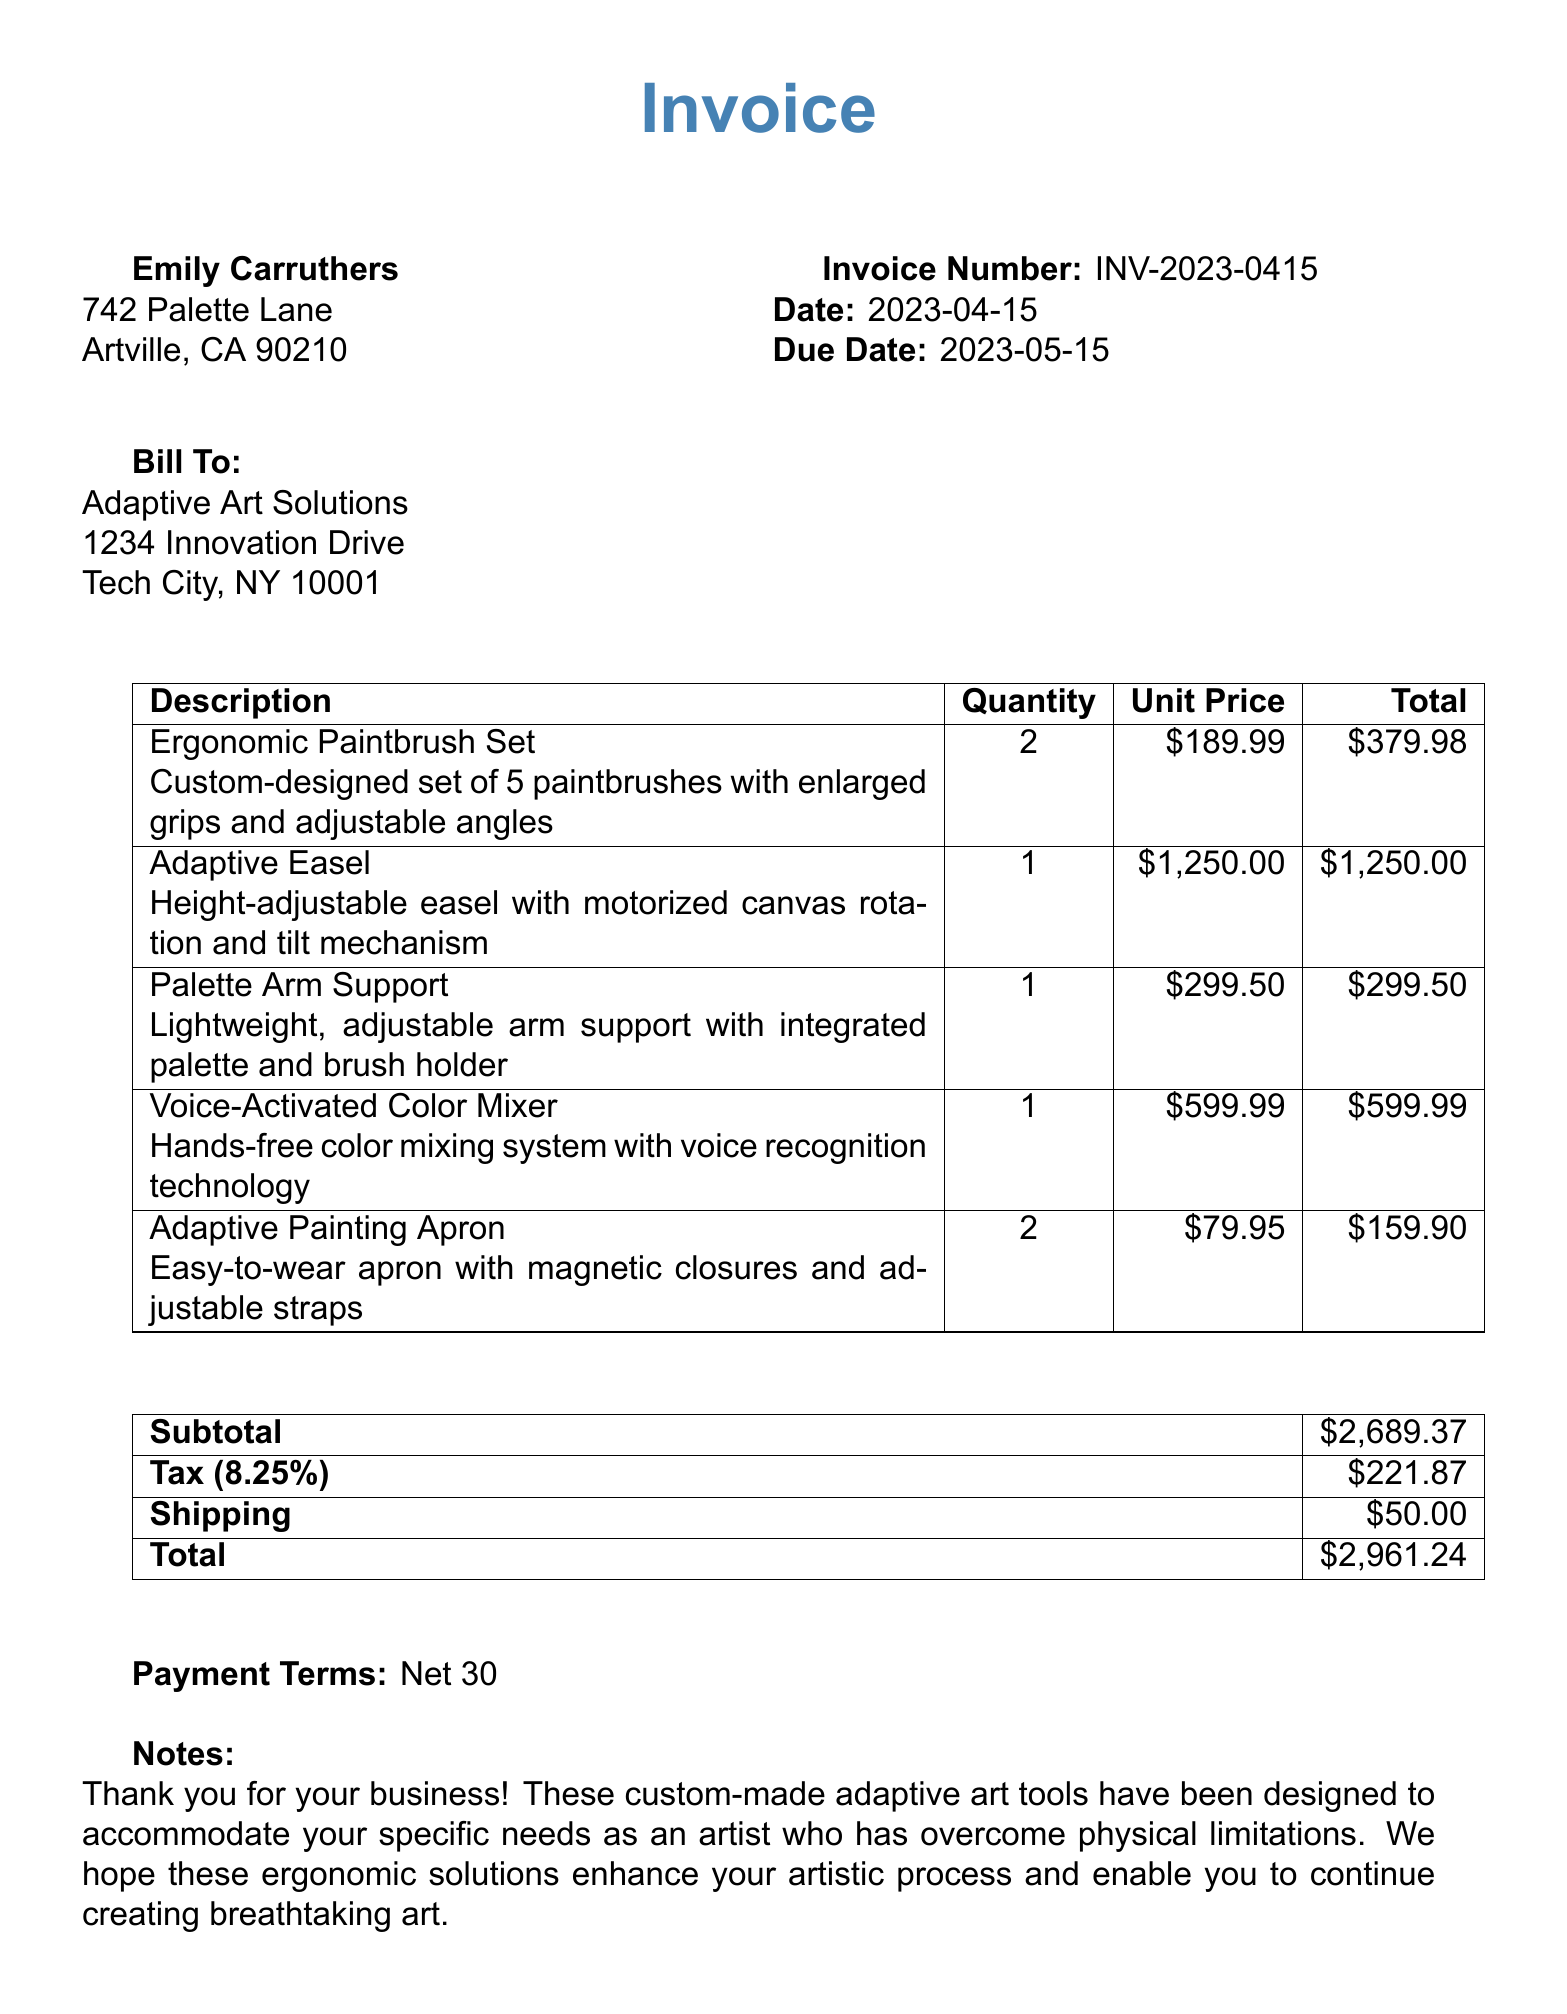What is the invoice number? The invoice number is clearly listed in the document, specifically noted as INV-2023-0415.
Answer: INV-2023-0415 What is the date of the invoice? The date of the invoice is provided in the document, stated as April 15, 2023.
Answer: 2023-04-15 How many ergonomic paintbrush sets were ordered? The quantity of ergonomic paintbrush sets is specified in the item list section, which shows a quantity of two.
Answer: 2 What is the total price for the adaptive easel? The total price for the adaptive easel can be found next to its item description, listed as $1,250.00.
Answer: $1,250.00 What is the subtotal amount? The subtotal amount is mentioned in the totals section of the document, which is $2,689.37.
Answer: $2,689.37 What ergonomic feature allows the voice-activated color mixer to function hands-free? The functionality of the voice-activated color mixer is attributed to its voice recognition technology, enabling hands-free use.
Answer: Voice recognition technology What is the weight capacity of the adaptive easel? The weight capacity of the adaptive easel is indicated in its ergonomic specifications, specified as 50 lbs.
Answer: 50 lbs How many colors can the voice-activated color mixer mix simultaneously? The color mixing capacity of the device is detailed in the ergonomic specifications, stating it can mix up to ten colors at once.
Answer: up to 10 colors What type of payment terms are mentioned in the document? The document mentions payment terms, specifically stating "Net 30" for payment.
Answer: Net 30 